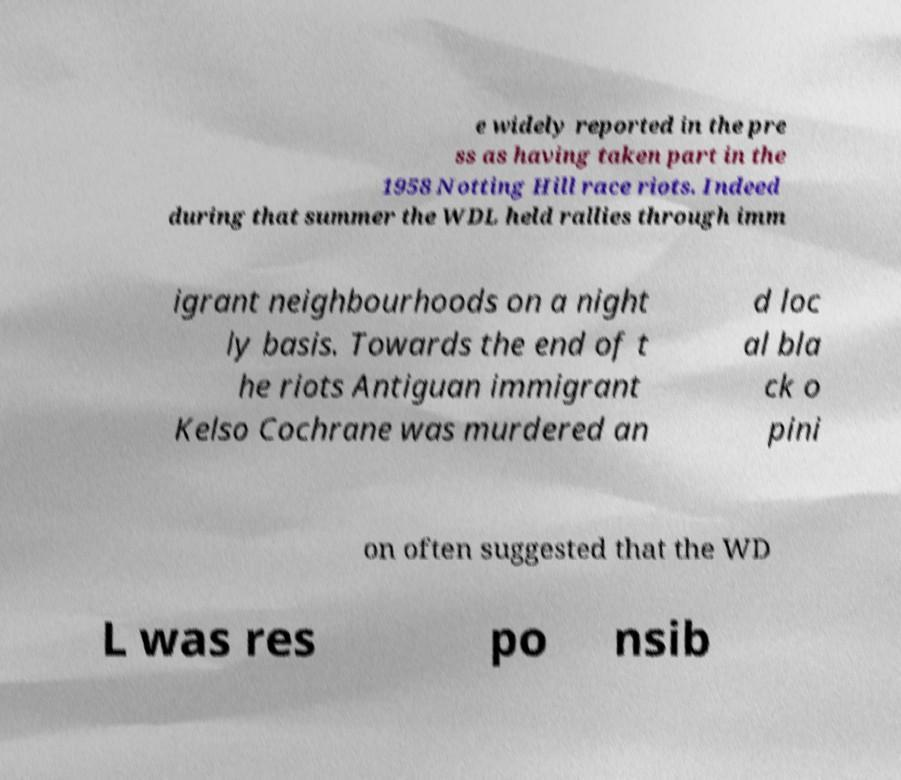Please identify and transcribe the text found in this image. e widely reported in the pre ss as having taken part in the 1958 Notting Hill race riots. Indeed during that summer the WDL held rallies through imm igrant neighbourhoods on a night ly basis. Towards the end of t he riots Antiguan immigrant Kelso Cochrane was murdered an d loc al bla ck o pini on often suggested that the WD L was res po nsib 